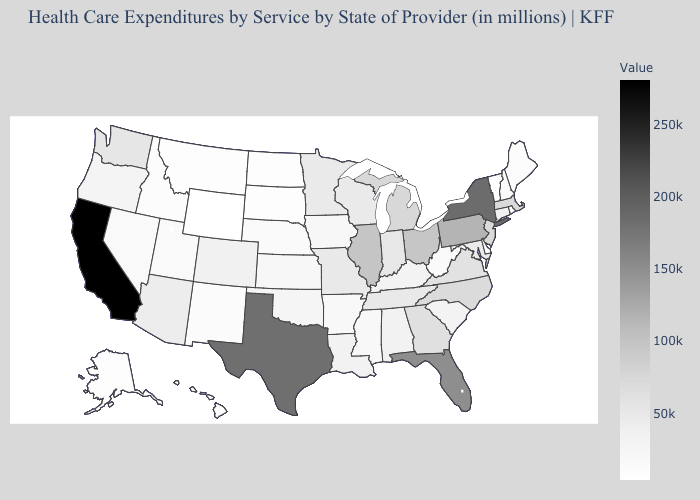Does the map have missing data?
Write a very short answer. No. Does the map have missing data?
Be succinct. No. Does California have the highest value in the West?
Be succinct. Yes. Does Indiana have the highest value in the USA?
Be succinct. No. Among the states that border Iowa , does South Dakota have the highest value?
Write a very short answer. No. 